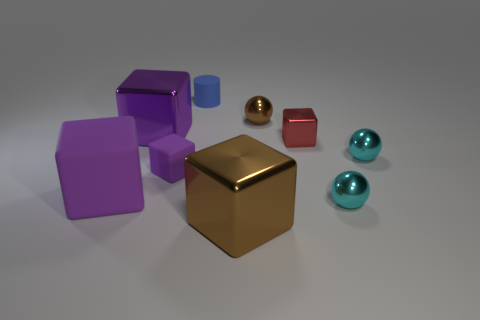Subtract all brown balls. How many balls are left? 2 Subtract all brown balls. How many balls are left? 2 Subtract all cyan balls. How many cyan cylinders are left? 0 Subtract all cubes. How many objects are left? 4 Subtract all gray cubes. Subtract all green balls. How many cubes are left? 5 Subtract all big shiny cylinders. Subtract all small cylinders. How many objects are left? 8 Add 7 purple objects. How many purple objects are left? 10 Add 3 purple metal blocks. How many purple metal blocks exist? 4 Subtract 0 red cylinders. How many objects are left? 9 Subtract 4 blocks. How many blocks are left? 1 